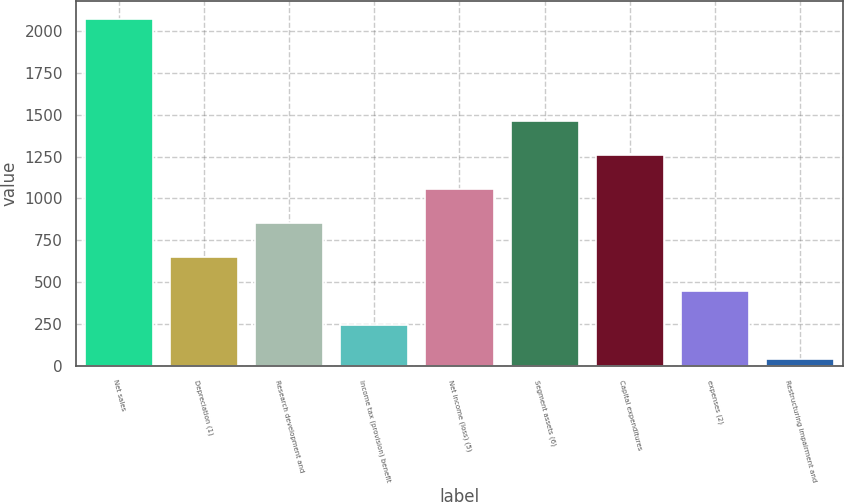Convert chart to OTSL. <chart><loc_0><loc_0><loc_500><loc_500><bar_chart><fcel>Net sales<fcel>Depreciation (1)<fcel>Research development and<fcel>Income tax (provision) benefit<fcel>Net income (loss) (5)<fcel>Segment assets (6)<fcel>Capital expenditures<fcel>expenses (2)<fcel>Restructuring impairment and<nl><fcel>2072<fcel>651<fcel>854<fcel>245<fcel>1057<fcel>1463<fcel>1260<fcel>448<fcel>42<nl></chart> 